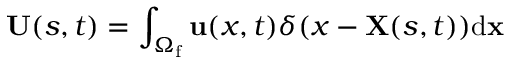Convert formula to latex. <formula><loc_0><loc_0><loc_500><loc_500>{ U } ( s , t ) = \int _ { { \Omega _ { f } } } { u } ( x , t ) \delta ( x - { X } ( s , t ) ) { d } { x }</formula> 